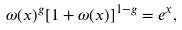<formula> <loc_0><loc_0><loc_500><loc_500>\omega ( x ) ^ { g } [ 1 + \omega ( x ) ] ^ { 1 - g } = e ^ { x } ,</formula> 